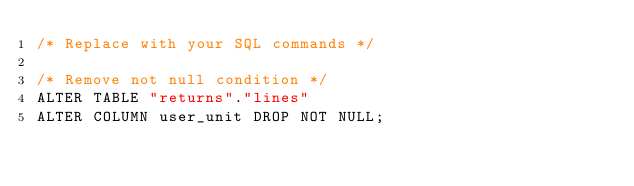Convert code to text. <code><loc_0><loc_0><loc_500><loc_500><_SQL_>/* Replace with your SQL commands */

/* Remove not null condition */
ALTER TABLE "returns"."lines"
ALTER COLUMN user_unit DROP NOT NULL;
</code> 